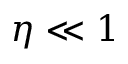Convert formula to latex. <formula><loc_0><loc_0><loc_500><loc_500>\eta \ll 1</formula> 